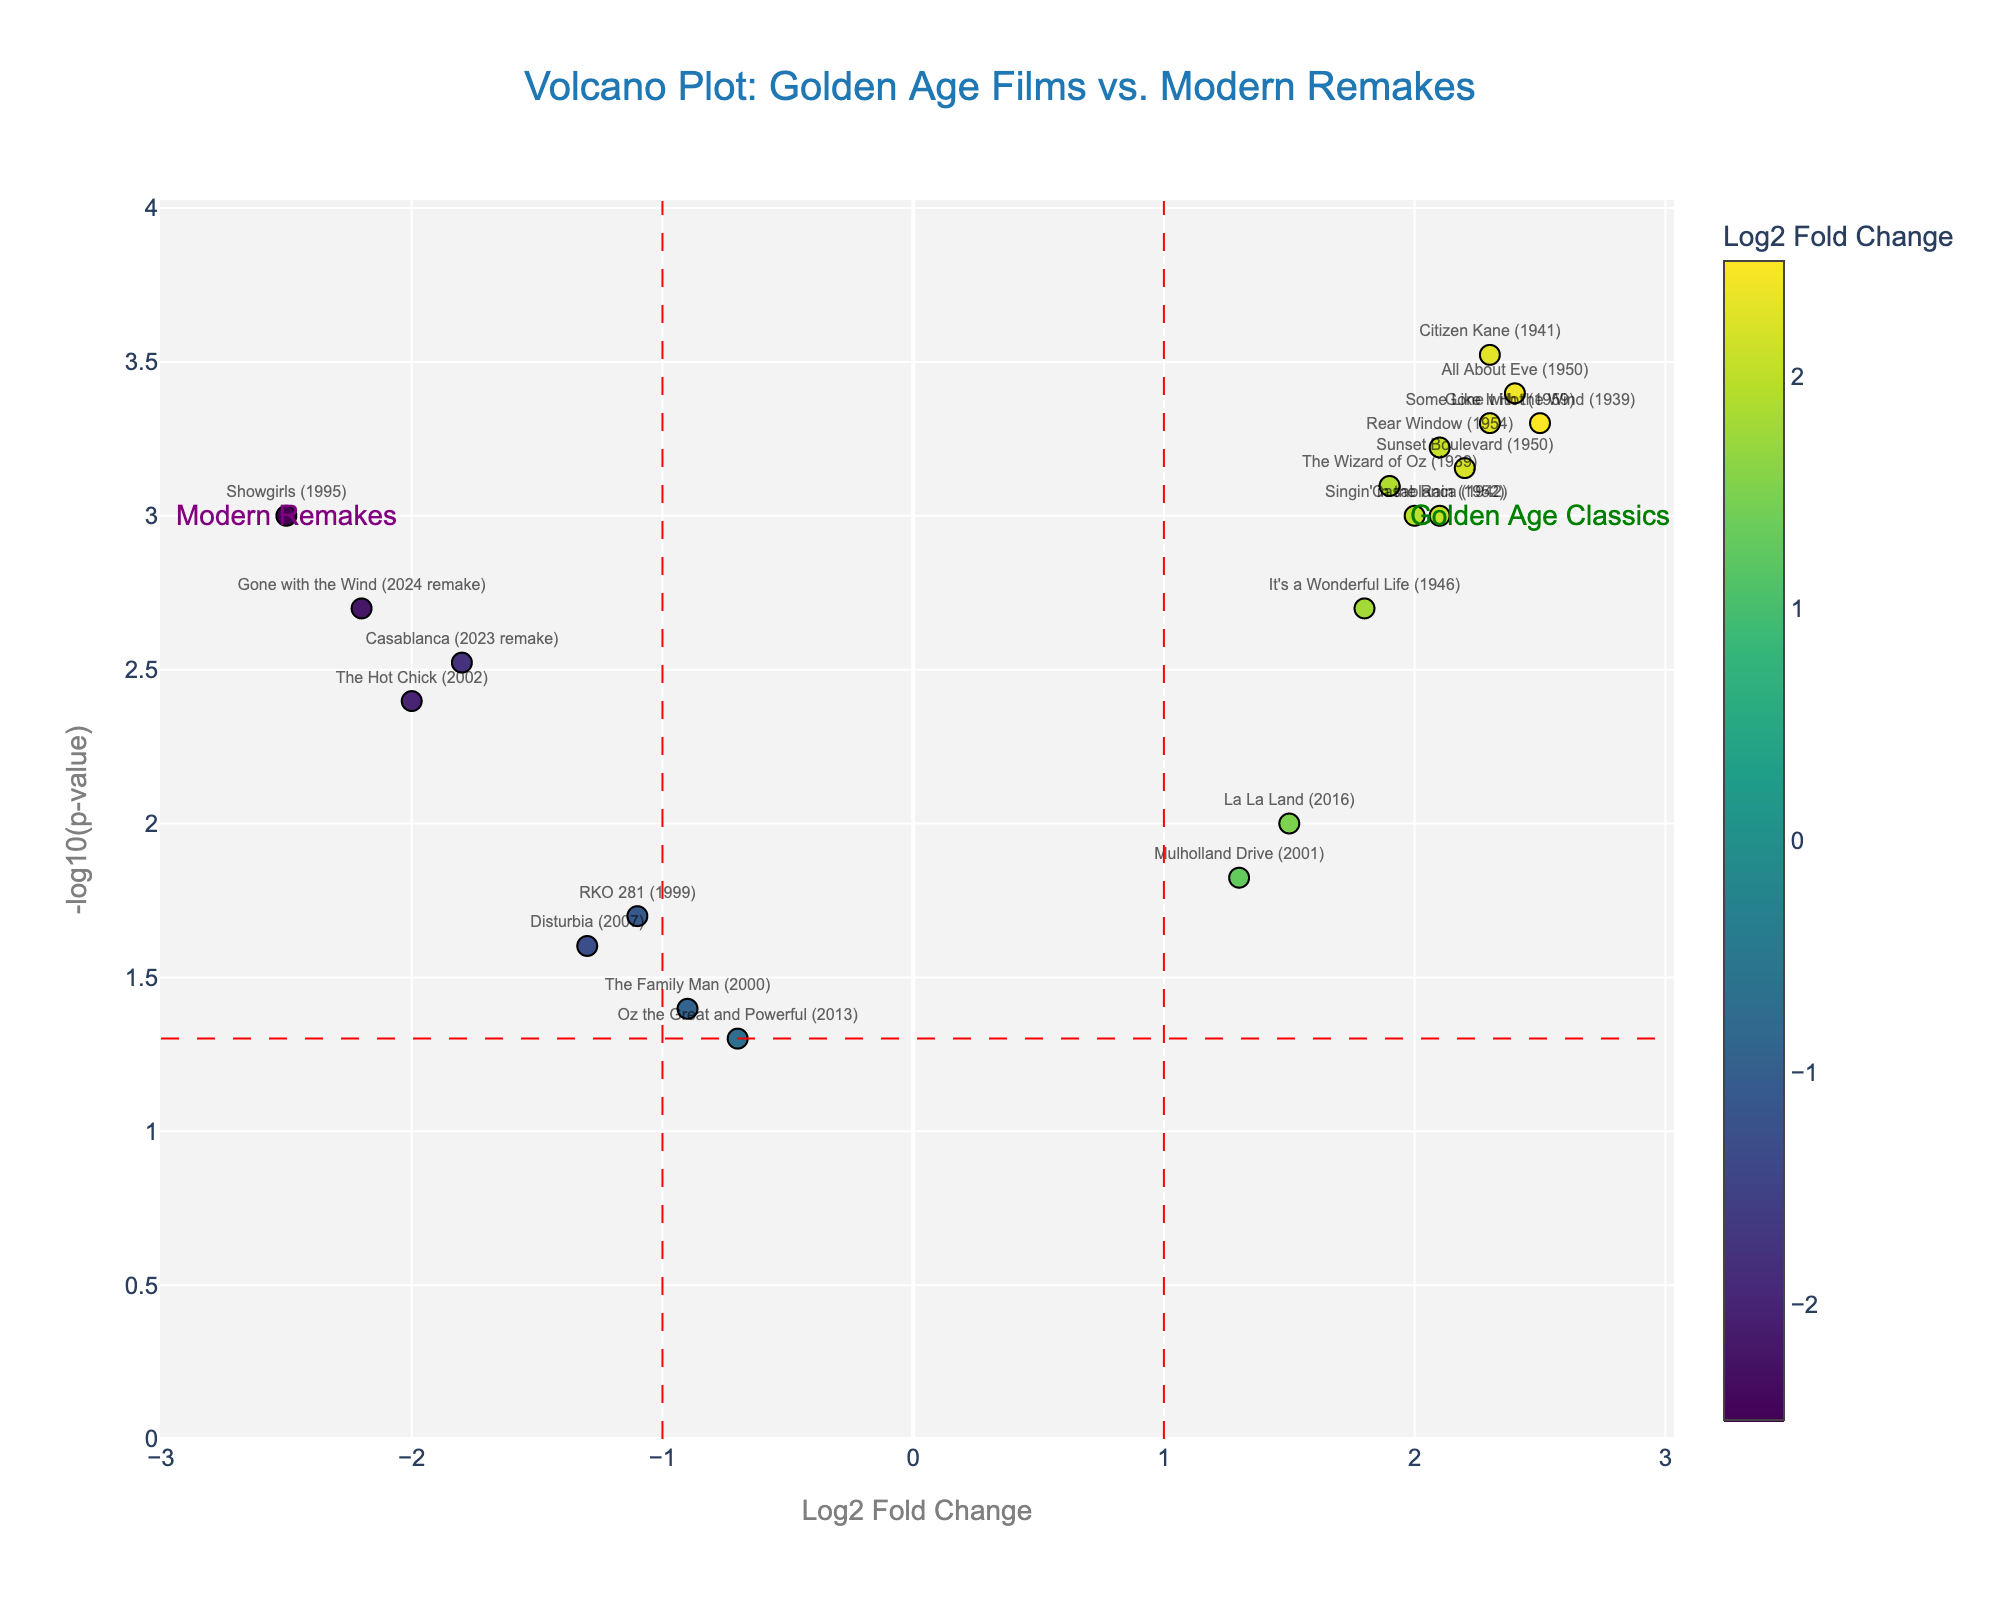what is the title of the plot? The title of the plot is written at the top center of the figure and reads: "Volcano Plot: Golden Age Films vs. Modern Remakes".
Answer: Volcano Plot: Golden Age Films vs. Modern Remakes what does the x-axis represent? Labels usually positioned along the horizontal line at the bottom of the plot indicate that the x-axis represents "Log2 Fold Change".
Answer: Log2 Fold Change How many films fall into the "Golden Age Classics" annotation region? The figure includes an annotation labeled "Golden Age Classics" on the right side of the plot. Count the number of data points (markers) on the right side where the annotation is placed.
Answer: 10 What film has the highest -log10(p-value)? The highest -log10(p-value) can be identified by locating the data point that is positioned highest on the y-axis and checking the label associated with that marker.
Answer: Citizen Kane (1941) Which remake film has the most significant negative Log2 Fold Change? To find the remake film with the most significant negative Log2 Fold Change, locate the data point farthest to the left (most negative) on the x-axis associated with a remake and check its label.
Answer: Showgirls (1995) Compare the p-value for Casablanca (1942) and Casablanca (2023 remake). Which is more significant? In a volcano plot, a lower p-value corresponds to a higher -log10(p-value). Locate both films and compare their positions on the y-axis where higher values denote more significance.
Answer: Casablanca (1942) What is the Log2 Fold Change for the film Gone with the Wind (1939)? Locate the marker labeled "Gone with the Wind (1939)" on the plot and check its x-axis position to find the Log2 Fold Change value.
Answer: 2.5 Which modern remake has a Log2 Fold Change greater than -1.0? Search for modern remakes whose markers are positioned right of -1.0 on the x-axis and list the films.
Answer: Oz the Great and Powerful (2013), La La Land (2016) What does a position above the red dashed horizontal line indicate about a film's p-value? The red dashed horizontal line represents a p-value threshold, typically set at 0.05. A position above this line indicates a p-value less than 0.05, implying greater statistical significance.
Answer: p-value less than 0.05 How many films have a Log2 Fold Change greater than 1 and a significant p-value? Locate all markers with x-axis values greater than 1 (right of the vertical dashed red line) and above the red horizontal line (significant p-value) and count them.
Answer: 9 